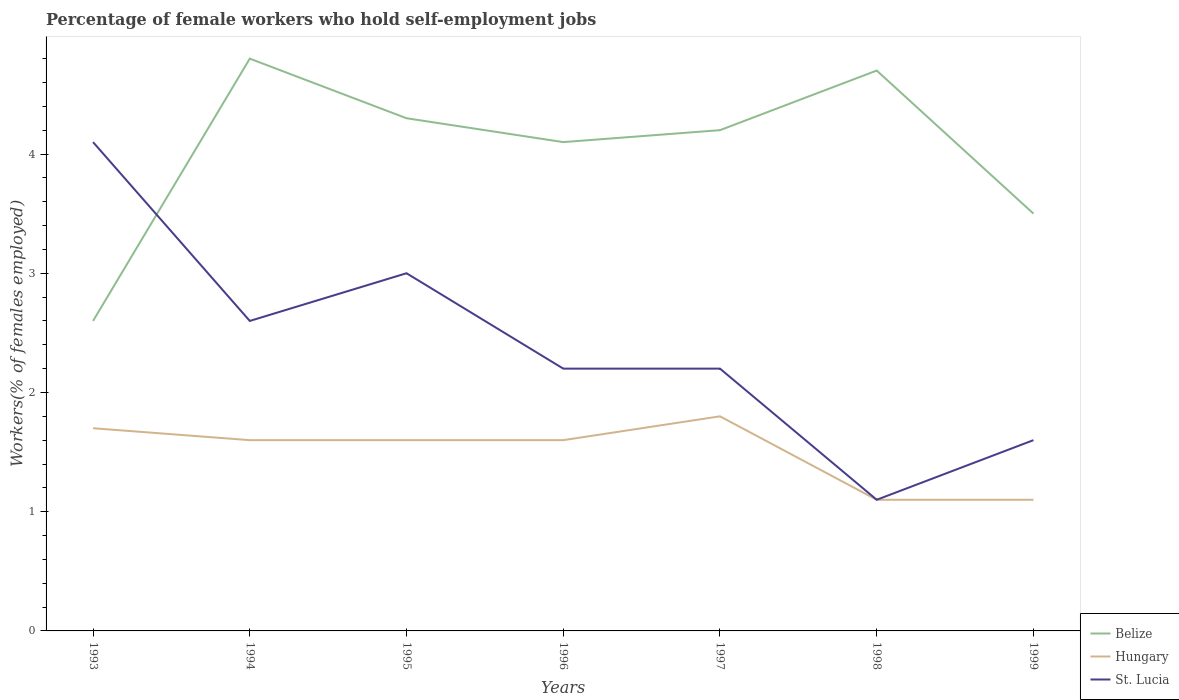How many different coloured lines are there?
Offer a very short reply. 3. Is the number of lines equal to the number of legend labels?
Offer a very short reply. Yes. Across all years, what is the maximum percentage of self-employed female workers in Belize?
Provide a short and direct response. 2.6. In which year was the percentage of self-employed female workers in Belize maximum?
Ensure brevity in your answer.  1993. What is the total percentage of self-employed female workers in St. Lucia in the graph?
Give a very brief answer. -0.5. What is the difference between the highest and the second highest percentage of self-employed female workers in St. Lucia?
Keep it short and to the point. 3. What is the difference between the highest and the lowest percentage of self-employed female workers in St. Lucia?
Ensure brevity in your answer.  3. How many lines are there?
Offer a very short reply. 3. How many years are there in the graph?
Give a very brief answer. 7. What is the title of the graph?
Ensure brevity in your answer.  Percentage of female workers who hold self-employment jobs. Does "Guinea" appear as one of the legend labels in the graph?
Keep it short and to the point. No. What is the label or title of the Y-axis?
Offer a very short reply. Workers(% of females employed). What is the Workers(% of females employed) of Belize in 1993?
Provide a short and direct response. 2.6. What is the Workers(% of females employed) in Hungary in 1993?
Give a very brief answer. 1.7. What is the Workers(% of females employed) of St. Lucia in 1993?
Your answer should be very brief. 4.1. What is the Workers(% of females employed) of Belize in 1994?
Your answer should be compact. 4.8. What is the Workers(% of females employed) in Hungary in 1994?
Your answer should be compact. 1.6. What is the Workers(% of females employed) of St. Lucia in 1994?
Provide a succinct answer. 2.6. What is the Workers(% of females employed) in Belize in 1995?
Provide a succinct answer. 4.3. What is the Workers(% of females employed) in Hungary in 1995?
Keep it short and to the point. 1.6. What is the Workers(% of females employed) of Belize in 1996?
Your answer should be compact. 4.1. What is the Workers(% of females employed) of Hungary in 1996?
Ensure brevity in your answer.  1.6. What is the Workers(% of females employed) in St. Lucia in 1996?
Keep it short and to the point. 2.2. What is the Workers(% of females employed) in Belize in 1997?
Give a very brief answer. 4.2. What is the Workers(% of females employed) of Hungary in 1997?
Your answer should be compact. 1.8. What is the Workers(% of females employed) of St. Lucia in 1997?
Give a very brief answer. 2.2. What is the Workers(% of females employed) in Belize in 1998?
Provide a short and direct response. 4.7. What is the Workers(% of females employed) in Hungary in 1998?
Give a very brief answer. 1.1. What is the Workers(% of females employed) in St. Lucia in 1998?
Your answer should be very brief. 1.1. What is the Workers(% of females employed) of Hungary in 1999?
Your answer should be compact. 1.1. What is the Workers(% of females employed) in St. Lucia in 1999?
Offer a terse response. 1.6. Across all years, what is the maximum Workers(% of females employed) in Belize?
Your answer should be very brief. 4.8. Across all years, what is the maximum Workers(% of females employed) in Hungary?
Your answer should be very brief. 1.8. Across all years, what is the maximum Workers(% of females employed) of St. Lucia?
Ensure brevity in your answer.  4.1. Across all years, what is the minimum Workers(% of females employed) in Belize?
Provide a short and direct response. 2.6. Across all years, what is the minimum Workers(% of females employed) of Hungary?
Ensure brevity in your answer.  1.1. Across all years, what is the minimum Workers(% of females employed) of St. Lucia?
Ensure brevity in your answer.  1.1. What is the total Workers(% of females employed) in Belize in the graph?
Provide a short and direct response. 28.2. What is the total Workers(% of females employed) in Hungary in the graph?
Offer a terse response. 10.5. What is the difference between the Workers(% of females employed) of Hungary in 1993 and that in 1994?
Offer a terse response. 0.1. What is the difference between the Workers(% of females employed) in St. Lucia in 1993 and that in 1994?
Your answer should be compact. 1.5. What is the difference between the Workers(% of females employed) in Belize in 1993 and that in 1995?
Your answer should be compact. -1.7. What is the difference between the Workers(% of females employed) in Hungary in 1993 and that in 1995?
Your response must be concise. 0.1. What is the difference between the Workers(% of females employed) of Hungary in 1993 and that in 1996?
Your answer should be very brief. 0.1. What is the difference between the Workers(% of females employed) of St. Lucia in 1993 and that in 1996?
Your answer should be very brief. 1.9. What is the difference between the Workers(% of females employed) in Belize in 1993 and that in 1997?
Provide a short and direct response. -1.6. What is the difference between the Workers(% of females employed) of Belize in 1993 and that in 1998?
Offer a terse response. -2.1. What is the difference between the Workers(% of females employed) in St. Lucia in 1993 and that in 1998?
Provide a short and direct response. 3. What is the difference between the Workers(% of females employed) in Hungary in 1994 and that in 1996?
Give a very brief answer. 0. What is the difference between the Workers(% of females employed) in Belize in 1994 and that in 1997?
Make the answer very short. 0.6. What is the difference between the Workers(% of females employed) of Hungary in 1994 and that in 1997?
Ensure brevity in your answer.  -0.2. What is the difference between the Workers(% of females employed) of St. Lucia in 1994 and that in 1997?
Offer a very short reply. 0.4. What is the difference between the Workers(% of females employed) of Belize in 1994 and that in 1998?
Keep it short and to the point. 0.1. What is the difference between the Workers(% of females employed) of Hungary in 1994 and that in 1998?
Your answer should be compact. 0.5. What is the difference between the Workers(% of females employed) of St. Lucia in 1994 and that in 1998?
Make the answer very short. 1.5. What is the difference between the Workers(% of females employed) of Hungary in 1994 and that in 1999?
Offer a terse response. 0.5. What is the difference between the Workers(% of females employed) of St. Lucia in 1994 and that in 1999?
Your answer should be very brief. 1. What is the difference between the Workers(% of females employed) of Hungary in 1995 and that in 1996?
Offer a very short reply. 0. What is the difference between the Workers(% of females employed) in Hungary in 1995 and that in 1997?
Give a very brief answer. -0.2. What is the difference between the Workers(% of females employed) in St. Lucia in 1995 and that in 1997?
Make the answer very short. 0.8. What is the difference between the Workers(% of females employed) in St. Lucia in 1995 and that in 1998?
Keep it short and to the point. 1.9. What is the difference between the Workers(% of females employed) of Hungary in 1995 and that in 1999?
Ensure brevity in your answer.  0.5. What is the difference between the Workers(% of females employed) of Belize in 1996 and that in 1997?
Provide a succinct answer. -0.1. What is the difference between the Workers(% of females employed) in Hungary in 1996 and that in 1997?
Your answer should be compact. -0.2. What is the difference between the Workers(% of females employed) of Hungary in 1996 and that in 1998?
Your response must be concise. 0.5. What is the difference between the Workers(% of females employed) in Belize in 1996 and that in 1999?
Offer a terse response. 0.6. What is the difference between the Workers(% of females employed) of Hungary in 1997 and that in 1998?
Keep it short and to the point. 0.7. What is the difference between the Workers(% of females employed) in St. Lucia in 1997 and that in 1998?
Offer a very short reply. 1.1. What is the difference between the Workers(% of females employed) in Hungary in 1997 and that in 1999?
Provide a short and direct response. 0.7. What is the difference between the Workers(% of females employed) of Hungary in 1998 and that in 1999?
Your answer should be compact. 0. What is the difference between the Workers(% of females employed) in Belize in 1993 and the Workers(% of females employed) in Hungary in 1994?
Your answer should be compact. 1. What is the difference between the Workers(% of females employed) of Belize in 1993 and the Workers(% of females employed) of St. Lucia in 1994?
Provide a succinct answer. 0. What is the difference between the Workers(% of females employed) in Belize in 1993 and the Workers(% of females employed) in Hungary in 1995?
Your response must be concise. 1. What is the difference between the Workers(% of females employed) of Belize in 1993 and the Workers(% of females employed) of St. Lucia in 1995?
Provide a succinct answer. -0.4. What is the difference between the Workers(% of females employed) in Belize in 1993 and the Workers(% of females employed) in Hungary in 1996?
Ensure brevity in your answer.  1. What is the difference between the Workers(% of females employed) of Belize in 1993 and the Workers(% of females employed) of St. Lucia in 1996?
Keep it short and to the point. 0.4. What is the difference between the Workers(% of females employed) of Hungary in 1993 and the Workers(% of females employed) of St. Lucia in 1996?
Keep it short and to the point. -0.5. What is the difference between the Workers(% of females employed) in Belize in 1993 and the Workers(% of females employed) in Hungary in 1997?
Provide a succinct answer. 0.8. What is the difference between the Workers(% of females employed) of Belize in 1993 and the Workers(% of females employed) of St. Lucia in 1998?
Keep it short and to the point. 1.5. What is the difference between the Workers(% of females employed) of Hungary in 1993 and the Workers(% of females employed) of St. Lucia in 1998?
Offer a very short reply. 0.6. What is the difference between the Workers(% of females employed) in Belize in 1993 and the Workers(% of females employed) in Hungary in 1999?
Offer a terse response. 1.5. What is the difference between the Workers(% of females employed) of Hungary in 1993 and the Workers(% of females employed) of St. Lucia in 1999?
Your answer should be compact. 0.1. What is the difference between the Workers(% of females employed) in Belize in 1994 and the Workers(% of females employed) in Hungary in 1995?
Your answer should be compact. 3.2. What is the difference between the Workers(% of females employed) of Hungary in 1994 and the Workers(% of females employed) of St. Lucia in 1995?
Provide a succinct answer. -1.4. What is the difference between the Workers(% of females employed) in Belize in 1994 and the Workers(% of females employed) in Hungary in 1996?
Provide a short and direct response. 3.2. What is the difference between the Workers(% of females employed) in Belize in 1994 and the Workers(% of females employed) in St. Lucia in 1996?
Make the answer very short. 2.6. What is the difference between the Workers(% of females employed) of Hungary in 1994 and the Workers(% of females employed) of St. Lucia in 1996?
Provide a short and direct response. -0.6. What is the difference between the Workers(% of females employed) of Hungary in 1994 and the Workers(% of females employed) of St. Lucia in 1998?
Offer a very short reply. 0.5. What is the difference between the Workers(% of females employed) of Belize in 1994 and the Workers(% of females employed) of Hungary in 1999?
Keep it short and to the point. 3.7. What is the difference between the Workers(% of females employed) of Belize in 1995 and the Workers(% of females employed) of Hungary in 1996?
Provide a succinct answer. 2.7. What is the difference between the Workers(% of females employed) in Belize in 1995 and the Workers(% of females employed) in St. Lucia in 1996?
Your answer should be very brief. 2.1. What is the difference between the Workers(% of females employed) in Hungary in 1995 and the Workers(% of females employed) in St. Lucia in 1997?
Ensure brevity in your answer.  -0.6. What is the difference between the Workers(% of females employed) of Belize in 1995 and the Workers(% of females employed) of Hungary in 1999?
Keep it short and to the point. 3.2. What is the difference between the Workers(% of females employed) in Hungary in 1995 and the Workers(% of females employed) in St. Lucia in 1999?
Make the answer very short. 0. What is the difference between the Workers(% of females employed) in Belize in 1996 and the Workers(% of females employed) in Hungary in 1997?
Keep it short and to the point. 2.3. What is the difference between the Workers(% of females employed) in Belize in 1996 and the Workers(% of females employed) in St. Lucia in 1997?
Offer a very short reply. 1.9. What is the difference between the Workers(% of females employed) of Hungary in 1996 and the Workers(% of females employed) of St. Lucia in 1997?
Your response must be concise. -0.6. What is the difference between the Workers(% of females employed) in Belize in 1996 and the Workers(% of females employed) in Hungary in 1998?
Your response must be concise. 3. What is the difference between the Workers(% of females employed) of Belize in 1996 and the Workers(% of females employed) of Hungary in 1999?
Offer a very short reply. 3. What is the difference between the Workers(% of females employed) of Belize in 1996 and the Workers(% of females employed) of St. Lucia in 1999?
Provide a short and direct response. 2.5. What is the difference between the Workers(% of females employed) of Belize in 1997 and the Workers(% of females employed) of Hungary in 1998?
Keep it short and to the point. 3.1. What is the difference between the Workers(% of females employed) of Belize in 1997 and the Workers(% of females employed) of St. Lucia in 1998?
Make the answer very short. 3.1. What is the difference between the Workers(% of females employed) of Hungary in 1997 and the Workers(% of females employed) of St. Lucia in 1998?
Offer a terse response. 0.7. What is the difference between the Workers(% of females employed) in Belize in 1998 and the Workers(% of females employed) in Hungary in 1999?
Make the answer very short. 3.6. What is the difference between the Workers(% of females employed) in Hungary in 1998 and the Workers(% of females employed) in St. Lucia in 1999?
Offer a very short reply. -0.5. What is the average Workers(% of females employed) of Belize per year?
Make the answer very short. 4.03. What is the average Workers(% of females employed) in Hungary per year?
Provide a short and direct response. 1.5. What is the average Workers(% of females employed) of St. Lucia per year?
Give a very brief answer. 2.4. In the year 1994, what is the difference between the Workers(% of females employed) in Belize and Workers(% of females employed) in Hungary?
Make the answer very short. 3.2. In the year 1994, what is the difference between the Workers(% of females employed) of Belize and Workers(% of females employed) of St. Lucia?
Your answer should be compact. 2.2. In the year 1994, what is the difference between the Workers(% of females employed) of Hungary and Workers(% of females employed) of St. Lucia?
Provide a short and direct response. -1. In the year 1996, what is the difference between the Workers(% of females employed) of Belize and Workers(% of females employed) of St. Lucia?
Give a very brief answer. 1.9. In the year 1996, what is the difference between the Workers(% of females employed) in Hungary and Workers(% of females employed) in St. Lucia?
Ensure brevity in your answer.  -0.6. In the year 1997, what is the difference between the Workers(% of females employed) in Belize and Workers(% of females employed) in Hungary?
Your response must be concise. 2.4. In the year 1997, what is the difference between the Workers(% of females employed) of Hungary and Workers(% of females employed) of St. Lucia?
Offer a very short reply. -0.4. In the year 1998, what is the difference between the Workers(% of females employed) in Belize and Workers(% of females employed) in St. Lucia?
Your answer should be very brief. 3.6. In the year 1998, what is the difference between the Workers(% of females employed) of Hungary and Workers(% of females employed) of St. Lucia?
Your answer should be compact. 0. What is the ratio of the Workers(% of females employed) of Belize in 1993 to that in 1994?
Your response must be concise. 0.54. What is the ratio of the Workers(% of females employed) in Hungary in 1993 to that in 1994?
Offer a terse response. 1.06. What is the ratio of the Workers(% of females employed) of St. Lucia in 1993 to that in 1994?
Offer a very short reply. 1.58. What is the ratio of the Workers(% of females employed) of Belize in 1993 to that in 1995?
Give a very brief answer. 0.6. What is the ratio of the Workers(% of females employed) in St. Lucia in 1993 to that in 1995?
Offer a very short reply. 1.37. What is the ratio of the Workers(% of females employed) of Belize in 1993 to that in 1996?
Your answer should be compact. 0.63. What is the ratio of the Workers(% of females employed) of St. Lucia in 1993 to that in 1996?
Make the answer very short. 1.86. What is the ratio of the Workers(% of females employed) of Belize in 1993 to that in 1997?
Provide a short and direct response. 0.62. What is the ratio of the Workers(% of females employed) of Hungary in 1993 to that in 1997?
Your answer should be compact. 0.94. What is the ratio of the Workers(% of females employed) of St. Lucia in 1993 to that in 1997?
Your response must be concise. 1.86. What is the ratio of the Workers(% of females employed) of Belize in 1993 to that in 1998?
Keep it short and to the point. 0.55. What is the ratio of the Workers(% of females employed) of Hungary in 1993 to that in 1998?
Keep it short and to the point. 1.55. What is the ratio of the Workers(% of females employed) in St. Lucia in 1993 to that in 1998?
Provide a succinct answer. 3.73. What is the ratio of the Workers(% of females employed) of Belize in 1993 to that in 1999?
Provide a succinct answer. 0.74. What is the ratio of the Workers(% of females employed) in Hungary in 1993 to that in 1999?
Make the answer very short. 1.55. What is the ratio of the Workers(% of females employed) of St. Lucia in 1993 to that in 1999?
Provide a short and direct response. 2.56. What is the ratio of the Workers(% of females employed) in Belize in 1994 to that in 1995?
Provide a short and direct response. 1.12. What is the ratio of the Workers(% of females employed) of St. Lucia in 1994 to that in 1995?
Make the answer very short. 0.87. What is the ratio of the Workers(% of females employed) of Belize in 1994 to that in 1996?
Provide a short and direct response. 1.17. What is the ratio of the Workers(% of females employed) of Hungary in 1994 to that in 1996?
Offer a terse response. 1. What is the ratio of the Workers(% of females employed) in St. Lucia in 1994 to that in 1996?
Make the answer very short. 1.18. What is the ratio of the Workers(% of females employed) of Belize in 1994 to that in 1997?
Your response must be concise. 1.14. What is the ratio of the Workers(% of females employed) of St. Lucia in 1994 to that in 1997?
Offer a terse response. 1.18. What is the ratio of the Workers(% of females employed) in Belize in 1994 to that in 1998?
Provide a short and direct response. 1.02. What is the ratio of the Workers(% of females employed) in Hungary in 1994 to that in 1998?
Ensure brevity in your answer.  1.45. What is the ratio of the Workers(% of females employed) of St. Lucia in 1994 to that in 1998?
Make the answer very short. 2.36. What is the ratio of the Workers(% of females employed) in Belize in 1994 to that in 1999?
Provide a short and direct response. 1.37. What is the ratio of the Workers(% of females employed) in Hungary in 1994 to that in 1999?
Your response must be concise. 1.45. What is the ratio of the Workers(% of females employed) in St. Lucia in 1994 to that in 1999?
Keep it short and to the point. 1.62. What is the ratio of the Workers(% of females employed) in Belize in 1995 to that in 1996?
Keep it short and to the point. 1.05. What is the ratio of the Workers(% of females employed) of St. Lucia in 1995 to that in 1996?
Make the answer very short. 1.36. What is the ratio of the Workers(% of females employed) of Belize in 1995 to that in 1997?
Offer a very short reply. 1.02. What is the ratio of the Workers(% of females employed) of Hungary in 1995 to that in 1997?
Offer a terse response. 0.89. What is the ratio of the Workers(% of females employed) of St. Lucia in 1995 to that in 1997?
Provide a succinct answer. 1.36. What is the ratio of the Workers(% of females employed) of Belize in 1995 to that in 1998?
Your response must be concise. 0.91. What is the ratio of the Workers(% of females employed) in Hungary in 1995 to that in 1998?
Your answer should be compact. 1.45. What is the ratio of the Workers(% of females employed) of St. Lucia in 1995 to that in 1998?
Make the answer very short. 2.73. What is the ratio of the Workers(% of females employed) in Belize in 1995 to that in 1999?
Your response must be concise. 1.23. What is the ratio of the Workers(% of females employed) of Hungary in 1995 to that in 1999?
Provide a short and direct response. 1.45. What is the ratio of the Workers(% of females employed) of St. Lucia in 1995 to that in 1999?
Give a very brief answer. 1.88. What is the ratio of the Workers(% of females employed) of Belize in 1996 to that in 1997?
Your answer should be compact. 0.98. What is the ratio of the Workers(% of females employed) in Belize in 1996 to that in 1998?
Your response must be concise. 0.87. What is the ratio of the Workers(% of females employed) in Hungary in 1996 to that in 1998?
Your response must be concise. 1.45. What is the ratio of the Workers(% of females employed) of Belize in 1996 to that in 1999?
Provide a short and direct response. 1.17. What is the ratio of the Workers(% of females employed) of Hungary in 1996 to that in 1999?
Offer a very short reply. 1.45. What is the ratio of the Workers(% of females employed) of St. Lucia in 1996 to that in 1999?
Keep it short and to the point. 1.38. What is the ratio of the Workers(% of females employed) of Belize in 1997 to that in 1998?
Offer a terse response. 0.89. What is the ratio of the Workers(% of females employed) of Hungary in 1997 to that in 1998?
Ensure brevity in your answer.  1.64. What is the ratio of the Workers(% of females employed) in St. Lucia in 1997 to that in 1998?
Ensure brevity in your answer.  2. What is the ratio of the Workers(% of females employed) in Belize in 1997 to that in 1999?
Ensure brevity in your answer.  1.2. What is the ratio of the Workers(% of females employed) of Hungary in 1997 to that in 1999?
Offer a terse response. 1.64. What is the ratio of the Workers(% of females employed) in St. Lucia in 1997 to that in 1999?
Offer a very short reply. 1.38. What is the ratio of the Workers(% of females employed) of Belize in 1998 to that in 1999?
Provide a short and direct response. 1.34. What is the ratio of the Workers(% of females employed) in St. Lucia in 1998 to that in 1999?
Make the answer very short. 0.69. What is the difference between the highest and the second highest Workers(% of females employed) of Belize?
Offer a terse response. 0.1. What is the difference between the highest and the second highest Workers(% of females employed) of Hungary?
Offer a terse response. 0.1. What is the difference between the highest and the second highest Workers(% of females employed) in St. Lucia?
Provide a succinct answer. 1.1. What is the difference between the highest and the lowest Workers(% of females employed) in St. Lucia?
Your response must be concise. 3. 